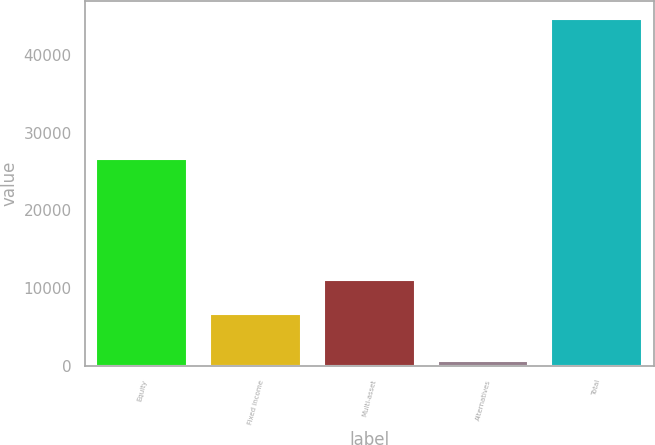<chart> <loc_0><loc_0><loc_500><loc_500><bar_chart><fcel>Equity<fcel>Fixed income<fcel>Multi-asset<fcel>Alternatives<fcel>Total<nl><fcel>26598<fcel>6655<fcel>11049<fcel>708<fcel>44648<nl></chart> 